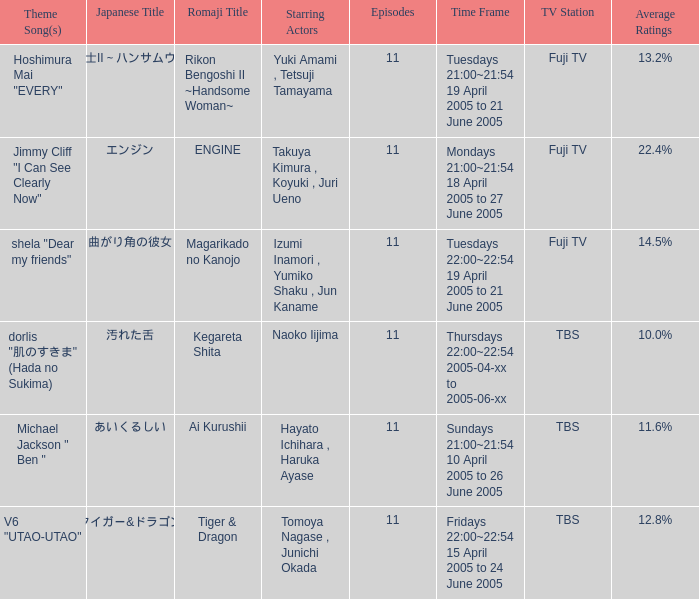Who is the star of the program on Thursdays 22:00~22:54 2005-04-xx to 2005-06-xx? Naoko Iijima. Give me the full table as a dictionary. {'header': ['Theme Song(s)', 'Japanese Title', 'Romaji Title', 'Starring Actors', 'Episodes', 'Time Frame', 'TV Station', 'Average Ratings'], 'rows': [['Hoshimura Mai "EVERY"', '離婚弁護士II～ハンサムウーマン～', 'Rikon Bengoshi II ~Handsome Woman~', 'Yuki Amami , Tetsuji Tamayama', '11', 'Tuesdays 21:00~21:54 19 April 2005 to 21 June 2005', 'Fuji TV', '13.2%'], ['Jimmy Cliff "I Can See Clearly Now"', 'エンジン', 'ENGINE', 'Takuya Kimura , Koyuki , Juri Ueno', '11', 'Mondays 21:00~21:54 18 April 2005 to 27 June 2005', 'Fuji TV', '22.4%'], ['shela "Dear my friends"', '曲がり角の彼女', 'Magarikado no Kanojo', 'Izumi Inamori , Yumiko Shaku , Jun Kaname', '11', 'Tuesdays 22:00~22:54 19 April 2005 to 21 June 2005', 'Fuji TV', '14.5%'], ['dorlis "肌のすきま" (Hada no Sukima)', '汚れた舌', 'Kegareta Shita', 'Naoko Iijima', '11', 'Thursdays 22:00~22:54 2005-04-xx to 2005-06-xx', 'TBS', '10.0%'], ['Michael Jackson " Ben "', 'あいくるしい', 'Ai Kurushii', 'Hayato Ichihara , Haruka Ayase', '11', 'Sundays 21:00~21:54 10 April 2005 to 26 June 2005', 'TBS', '11.6%'], ['V6 "UTAO-UTAO"', 'タイガー&ドラゴン', 'Tiger & Dragon', 'Tomoya Nagase , Junichi Okada', '11', 'Fridays 22:00~22:54 15 April 2005 to 24 June 2005', 'TBS', '12.8%']]} 